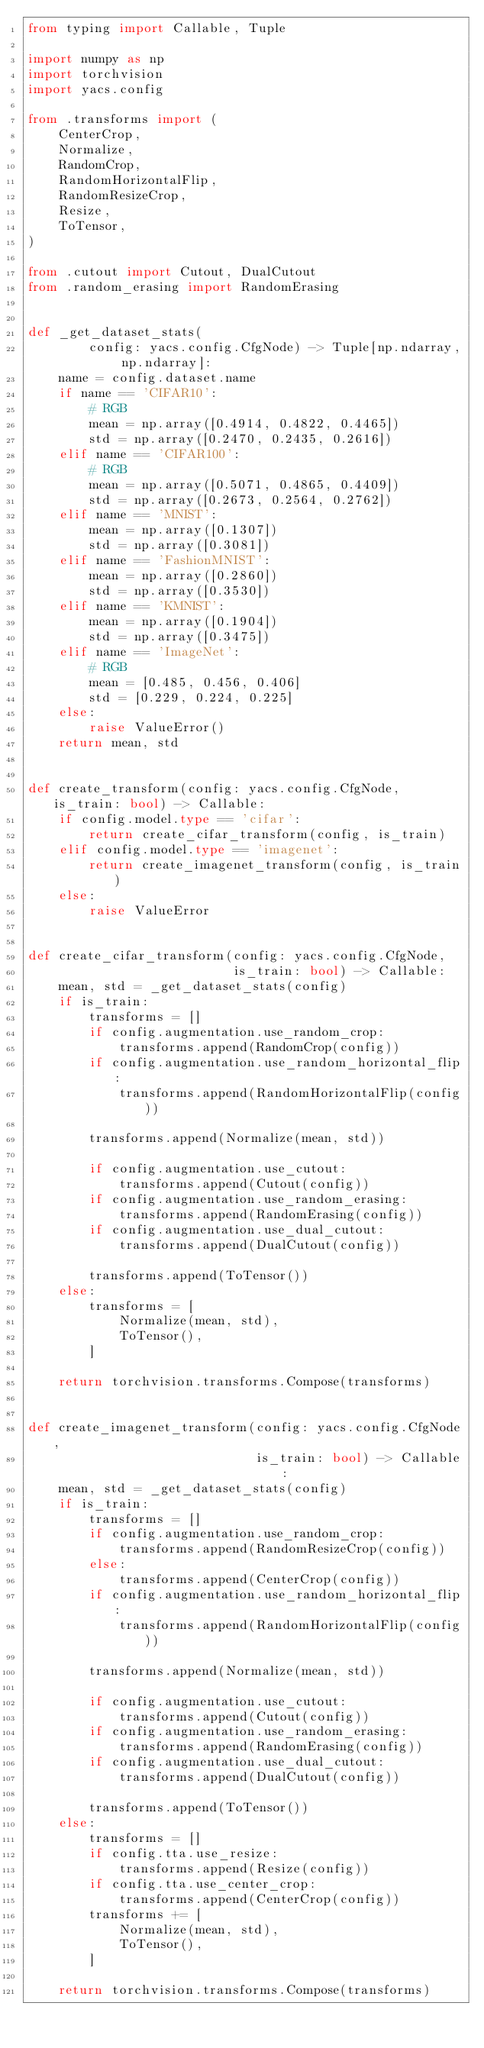Convert code to text. <code><loc_0><loc_0><loc_500><loc_500><_Python_>from typing import Callable, Tuple

import numpy as np
import torchvision
import yacs.config

from .transforms import (
    CenterCrop,
    Normalize,
    RandomCrop,
    RandomHorizontalFlip,
    RandomResizeCrop,
    Resize,
    ToTensor,
)

from .cutout import Cutout, DualCutout
from .random_erasing import RandomErasing


def _get_dataset_stats(
        config: yacs.config.CfgNode) -> Tuple[np.ndarray, np.ndarray]:
    name = config.dataset.name
    if name == 'CIFAR10':
        # RGB
        mean = np.array([0.4914, 0.4822, 0.4465])
        std = np.array([0.2470, 0.2435, 0.2616])
    elif name == 'CIFAR100':
        # RGB
        mean = np.array([0.5071, 0.4865, 0.4409])
        std = np.array([0.2673, 0.2564, 0.2762])
    elif name == 'MNIST':
        mean = np.array([0.1307])
        std = np.array([0.3081])
    elif name == 'FashionMNIST':
        mean = np.array([0.2860])
        std = np.array([0.3530])
    elif name == 'KMNIST':
        mean = np.array([0.1904])
        std = np.array([0.3475])
    elif name == 'ImageNet':
        # RGB
        mean = [0.485, 0.456, 0.406]
        std = [0.229, 0.224, 0.225]
    else:
        raise ValueError()
    return mean, std


def create_transform(config: yacs.config.CfgNode, is_train: bool) -> Callable:
    if config.model.type == 'cifar':
        return create_cifar_transform(config, is_train)
    elif config.model.type == 'imagenet':
        return create_imagenet_transform(config, is_train)
    else:
        raise ValueError


def create_cifar_transform(config: yacs.config.CfgNode,
                           is_train: bool) -> Callable:
    mean, std = _get_dataset_stats(config)
    if is_train:
        transforms = []
        if config.augmentation.use_random_crop:
            transforms.append(RandomCrop(config))
        if config.augmentation.use_random_horizontal_flip:
            transforms.append(RandomHorizontalFlip(config))

        transforms.append(Normalize(mean, std))

        if config.augmentation.use_cutout:
            transforms.append(Cutout(config))
        if config.augmentation.use_random_erasing:
            transforms.append(RandomErasing(config))
        if config.augmentation.use_dual_cutout:
            transforms.append(DualCutout(config))

        transforms.append(ToTensor())
    else:
        transforms = [
            Normalize(mean, std),
            ToTensor(),
        ]

    return torchvision.transforms.Compose(transforms)


def create_imagenet_transform(config: yacs.config.CfgNode,
                              is_train: bool) -> Callable:
    mean, std = _get_dataset_stats(config)
    if is_train:
        transforms = []
        if config.augmentation.use_random_crop:
            transforms.append(RandomResizeCrop(config))
        else:
            transforms.append(CenterCrop(config))
        if config.augmentation.use_random_horizontal_flip:
            transforms.append(RandomHorizontalFlip(config))

        transforms.append(Normalize(mean, std))

        if config.augmentation.use_cutout:
            transforms.append(Cutout(config))
        if config.augmentation.use_random_erasing:
            transforms.append(RandomErasing(config))
        if config.augmentation.use_dual_cutout:
            transforms.append(DualCutout(config))

        transforms.append(ToTensor())
    else:
        transforms = []
        if config.tta.use_resize:
            transforms.append(Resize(config))
        if config.tta.use_center_crop:
            transforms.append(CenterCrop(config))
        transforms += [
            Normalize(mean, std),
            ToTensor(),
        ]

    return torchvision.transforms.Compose(transforms)
</code> 